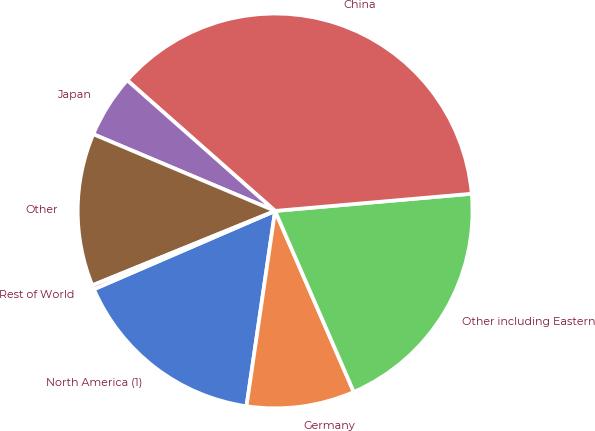Convert chart. <chart><loc_0><loc_0><loc_500><loc_500><pie_chart><fcel>North America (1)<fcel>Germany<fcel>Other including Eastern<fcel>China<fcel>Japan<fcel>Other<fcel>Rest of World<nl><fcel>16.19%<fcel>8.84%<fcel>19.86%<fcel>37.09%<fcel>5.16%<fcel>12.51%<fcel>0.34%<nl></chart> 